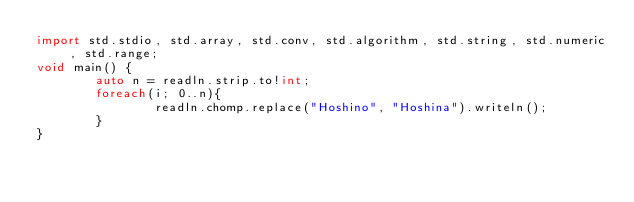Convert code to text. <code><loc_0><loc_0><loc_500><loc_500><_D_>import std.stdio, std.array, std.conv, std.algorithm, std.string, std.numeric, std.range;
void main() {
        auto n = readln.strip.to!int;
        foreach(i; 0..n){
                readln.chomp.replace("Hoshino", "Hoshina").writeln();
        }
}</code> 